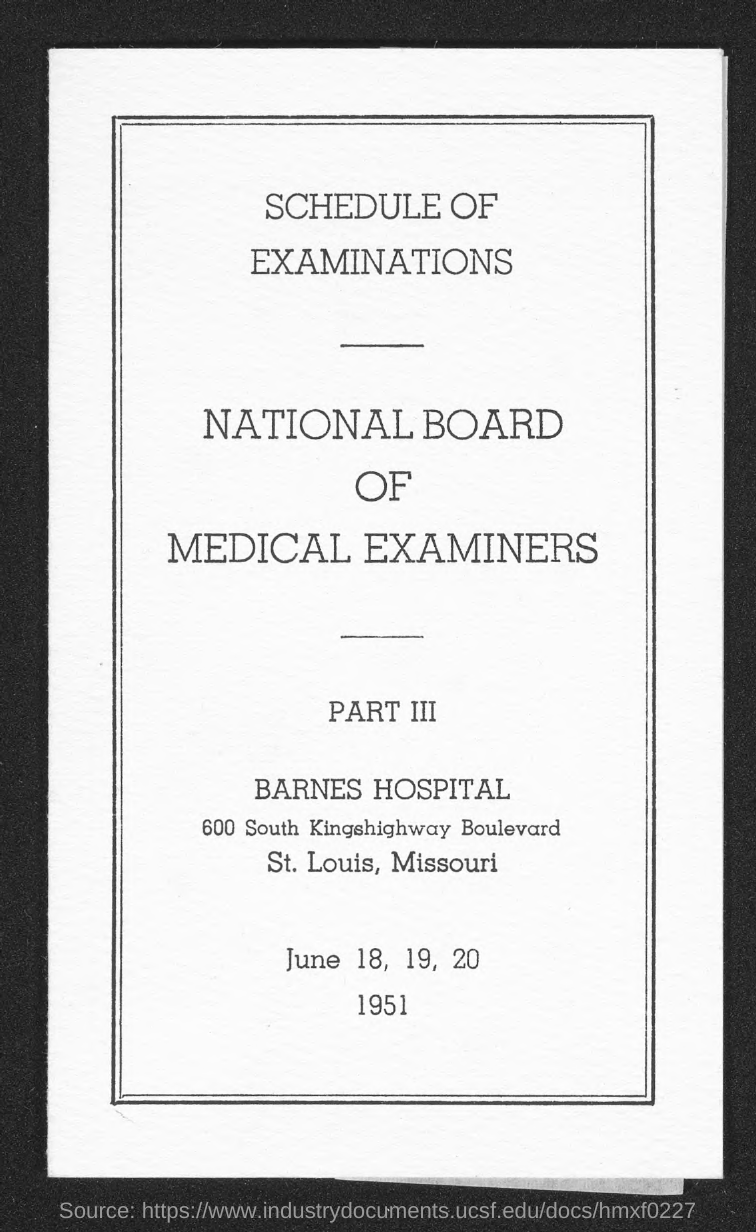List a handful of essential elements in this visual. Barnes Hospital is located in the state of Missouri. 